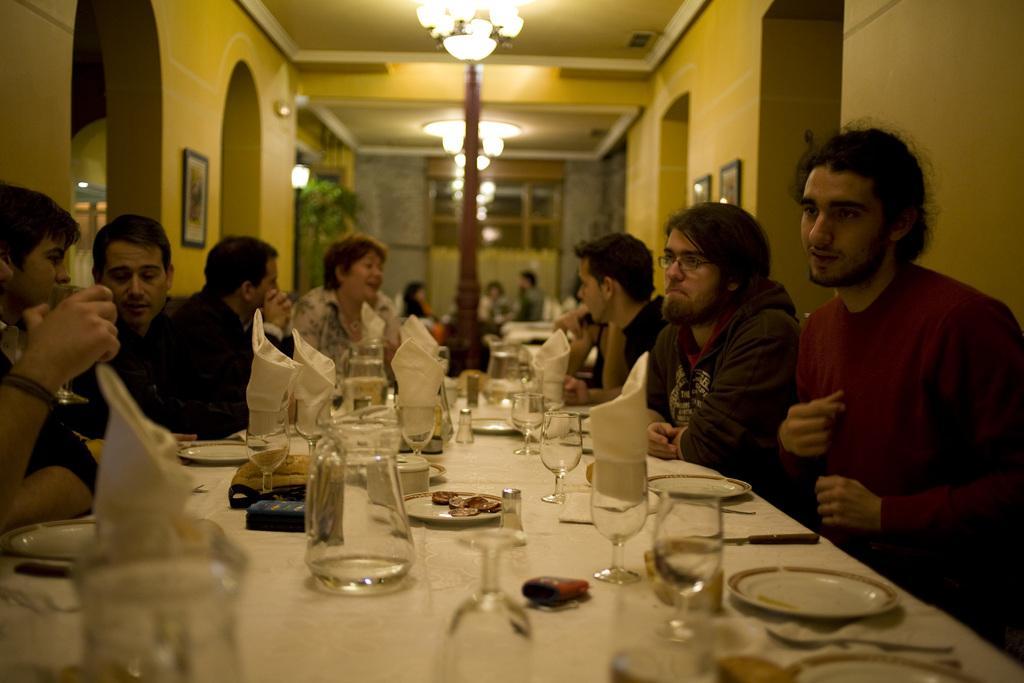How would you summarize this image in a sentence or two? This picture is taken in a restaurant. Here, we see many people sitting on chair. In front of the picture, we see a table on which jar, glass, plate, fork, spoon are placed on it and on background, we see other table dining table and behind that, we see a wall which is grey in color and on the left of the picture, we see a wall which is yellow in color and on wall, we see photo frame. On the right on the right side, we see two photo frames on the wall. 